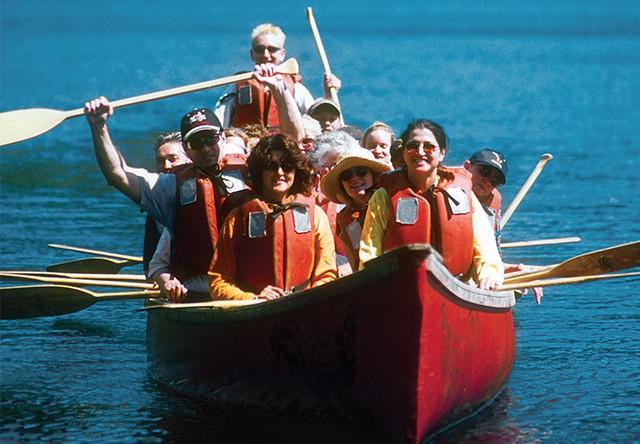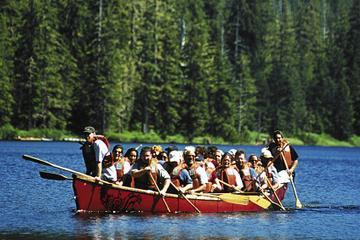The first image is the image on the left, the second image is the image on the right. Evaluate the accuracy of this statement regarding the images: "The right image shows one canoe, a leftward-headed red canoe with at least three rowers.". Is it true? Answer yes or no. Yes. The first image is the image on the left, the second image is the image on the right. Analyze the images presented: Is the assertion "The left and right image contains a total of two boats." valid? Answer yes or no. Yes. 